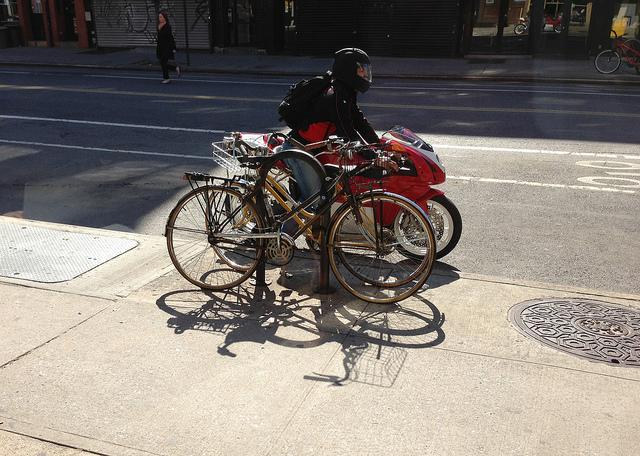In which lane does the person in the black helmet ride? Please explain your reasoning. right lane. The person is on the right lane. 